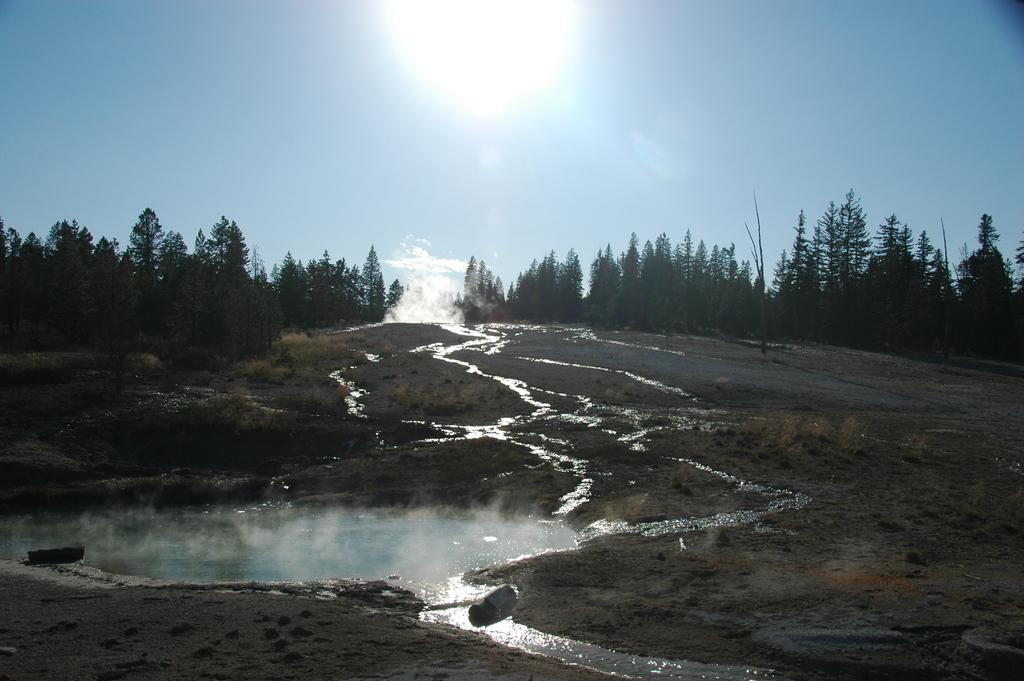What is present at the bottom of the picture? There is water and sand at the bottom of the picture. What can be seen in the background of the image? There are trees in the background of the image. What is visible at the top of the image? The sun is visible at the top of the image. What is the color of the sky in the image? The sky is blue in color. Can you tell me how many ornaments are hanging from the trees in the image? There are no ornaments present in the image; it features trees in the background. What type of haircut does the lake have in the image? There is no lake present in the image, and therefore no haircut can be observed. 